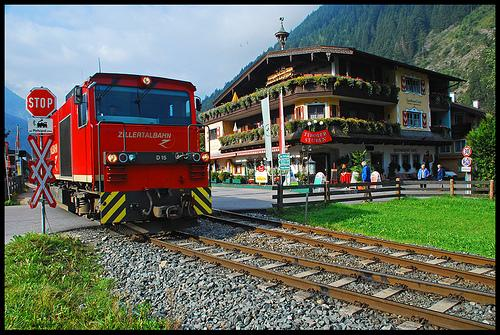What zone is this area? Please explain your reasoning. tourist. The main building in this photo is quite colorful and appears to one to attract people.  coupled with the train stop in this location, it would seem that this zone was built for tourists. 